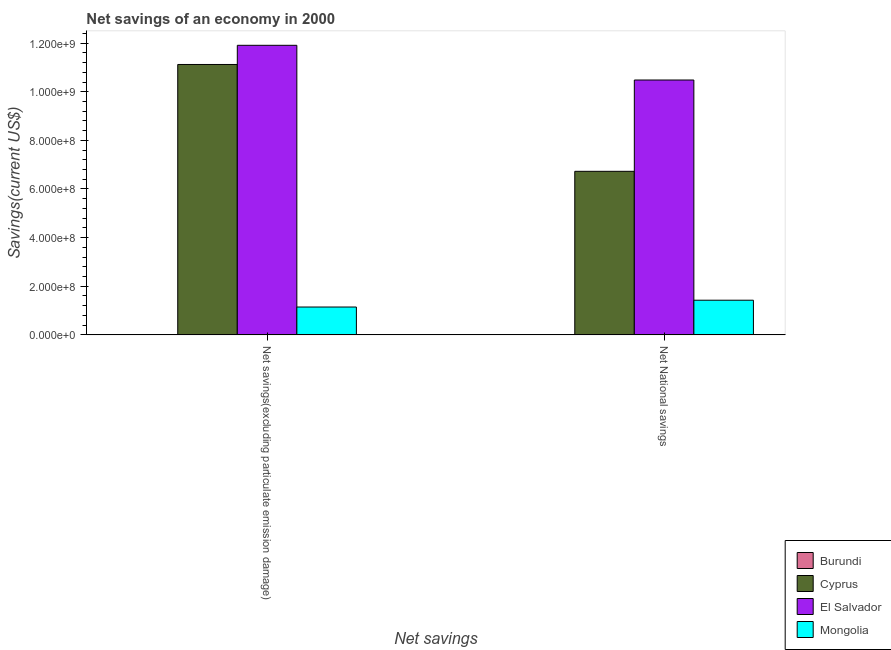How many groups of bars are there?
Your answer should be very brief. 2. Are the number of bars on each tick of the X-axis equal?
Offer a very short reply. Yes. How many bars are there on the 1st tick from the left?
Give a very brief answer. 3. What is the label of the 2nd group of bars from the left?
Keep it short and to the point. Net National savings. What is the net national savings in El Salvador?
Keep it short and to the point. 1.05e+09. Across all countries, what is the maximum net savings(excluding particulate emission damage)?
Provide a short and direct response. 1.19e+09. In which country was the net national savings maximum?
Your answer should be compact. El Salvador. What is the total net savings(excluding particulate emission damage) in the graph?
Your response must be concise. 2.42e+09. What is the difference between the net national savings in Cyprus and that in El Salvador?
Ensure brevity in your answer.  -3.75e+08. What is the difference between the net savings(excluding particulate emission damage) in El Salvador and the net national savings in Mongolia?
Provide a short and direct response. 1.05e+09. What is the average net savings(excluding particulate emission damage) per country?
Provide a succinct answer. 6.04e+08. What is the difference between the net national savings and net savings(excluding particulate emission damage) in El Salvador?
Your answer should be compact. -1.43e+08. What is the ratio of the net savings(excluding particulate emission damage) in Mongolia to that in Cyprus?
Give a very brief answer. 0.1. How many bars are there?
Offer a very short reply. 6. How many countries are there in the graph?
Keep it short and to the point. 4. Does the graph contain any zero values?
Ensure brevity in your answer.  Yes. Where does the legend appear in the graph?
Ensure brevity in your answer.  Bottom right. How many legend labels are there?
Give a very brief answer. 4. How are the legend labels stacked?
Keep it short and to the point. Vertical. What is the title of the graph?
Ensure brevity in your answer.  Net savings of an economy in 2000. What is the label or title of the X-axis?
Your response must be concise. Net savings. What is the label or title of the Y-axis?
Offer a very short reply. Savings(current US$). What is the Savings(current US$) in Cyprus in Net savings(excluding particulate emission damage)?
Your answer should be very brief. 1.11e+09. What is the Savings(current US$) in El Salvador in Net savings(excluding particulate emission damage)?
Provide a short and direct response. 1.19e+09. What is the Savings(current US$) in Mongolia in Net savings(excluding particulate emission damage)?
Your answer should be compact. 1.15e+08. What is the Savings(current US$) of Burundi in Net National savings?
Provide a succinct answer. 0. What is the Savings(current US$) of Cyprus in Net National savings?
Provide a short and direct response. 6.73e+08. What is the Savings(current US$) of El Salvador in Net National savings?
Your answer should be very brief. 1.05e+09. What is the Savings(current US$) in Mongolia in Net National savings?
Offer a very short reply. 1.43e+08. Across all Net savings, what is the maximum Savings(current US$) of Cyprus?
Make the answer very short. 1.11e+09. Across all Net savings, what is the maximum Savings(current US$) in El Salvador?
Make the answer very short. 1.19e+09. Across all Net savings, what is the maximum Savings(current US$) in Mongolia?
Make the answer very short. 1.43e+08. Across all Net savings, what is the minimum Savings(current US$) in Cyprus?
Offer a very short reply. 6.73e+08. Across all Net savings, what is the minimum Savings(current US$) in El Salvador?
Ensure brevity in your answer.  1.05e+09. Across all Net savings, what is the minimum Savings(current US$) in Mongolia?
Your response must be concise. 1.15e+08. What is the total Savings(current US$) of Burundi in the graph?
Your response must be concise. 0. What is the total Savings(current US$) of Cyprus in the graph?
Your answer should be very brief. 1.78e+09. What is the total Savings(current US$) in El Salvador in the graph?
Offer a very short reply. 2.24e+09. What is the total Savings(current US$) in Mongolia in the graph?
Your answer should be compact. 2.57e+08. What is the difference between the Savings(current US$) in Cyprus in Net savings(excluding particulate emission damage) and that in Net National savings?
Your response must be concise. 4.39e+08. What is the difference between the Savings(current US$) of El Salvador in Net savings(excluding particulate emission damage) and that in Net National savings?
Your answer should be very brief. 1.43e+08. What is the difference between the Savings(current US$) in Mongolia in Net savings(excluding particulate emission damage) and that in Net National savings?
Your answer should be very brief. -2.80e+07. What is the difference between the Savings(current US$) in Cyprus in Net savings(excluding particulate emission damage) and the Savings(current US$) in El Salvador in Net National savings?
Your answer should be compact. 6.39e+07. What is the difference between the Savings(current US$) in Cyprus in Net savings(excluding particulate emission damage) and the Savings(current US$) in Mongolia in Net National savings?
Your response must be concise. 9.69e+08. What is the difference between the Savings(current US$) in El Salvador in Net savings(excluding particulate emission damage) and the Savings(current US$) in Mongolia in Net National savings?
Give a very brief answer. 1.05e+09. What is the average Savings(current US$) in Cyprus per Net savings?
Ensure brevity in your answer.  8.92e+08. What is the average Savings(current US$) of El Salvador per Net savings?
Make the answer very short. 1.12e+09. What is the average Savings(current US$) of Mongolia per Net savings?
Offer a terse response. 1.29e+08. What is the difference between the Savings(current US$) in Cyprus and Savings(current US$) in El Salvador in Net savings(excluding particulate emission damage)?
Your response must be concise. -7.89e+07. What is the difference between the Savings(current US$) of Cyprus and Savings(current US$) of Mongolia in Net savings(excluding particulate emission damage)?
Your answer should be very brief. 9.97e+08. What is the difference between the Savings(current US$) of El Salvador and Savings(current US$) of Mongolia in Net savings(excluding particulate emission damage)?
Provide a short and direct response. 1.08e+09. What is the difference between the Savings(current US$) of Cyprus and Savings(current US$) of El Salvador in Net National savings?
Ensure brevity in your answer.  -3.75e+08. What is the difference between the Savings(current US$) of Cyprus and Savings(current US$) of Mongolia in Net National savings?
Ensure brevity in your answer.  5.30e+08. What is the difference between the Savings(current US$) in El Salvador and Savings(current US$) in Mongolia in Net National savings?
Provide a succinct answer. 9.06e+08. What is the ratio of the Savings(current US$) of Cyprus in Net savings(excluding particulate emission damage) to that in Net National savings?
Offer a terse response. 1.65. What is the ratio of the Savings(current US$) of El Salvador in Net savings(excluding particulate emission damage) to that in Net National savings?
Give a very brief answer. 1.14. What is the ratio of the Savings(current US$) of Mongolia in Net savings(excluding particulate emission damage) to that in Net National savings?
Give a very brief answer. 0.8. What is the difference between the highest and the second highest Savings(current US$) of Cyprus?
Provide a succinct answer. 4.39e+08. What is the difference between the highest and the second highest Savings(current US$) in El Salvador?
Offer a very short reply. 1.43e+08. What is the difference between the highest and the second highest Savings(current US$) of Mongolia?
Ensure brevity in your answer.  2.80e+07. What is the difference between the highest and the lowest Savings(current US$) of Cyprus?
Provide a succinct answer. 4.39e+08. What is the difference between the highest and the lowest Savings(current US$) of El Salvador?
Offer a terse response. 1.43e+08. What is the difference between the highest and the lowest Savings(current US$) in Mongolia?
Offer a very short reply. 2.80e+07. 